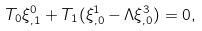Convert formula to latex. <formula><loc_0><loc_0><loc_500><loc_500>T _ { 0 } \xi ^ { 0 } _ { , 1 } + T _ { 1 } ( \xi ^ { 1 } _ { , 0 } - \Lambda \xi ^ { 3 } _ { , 0 } ) = 0 ,</formula> 